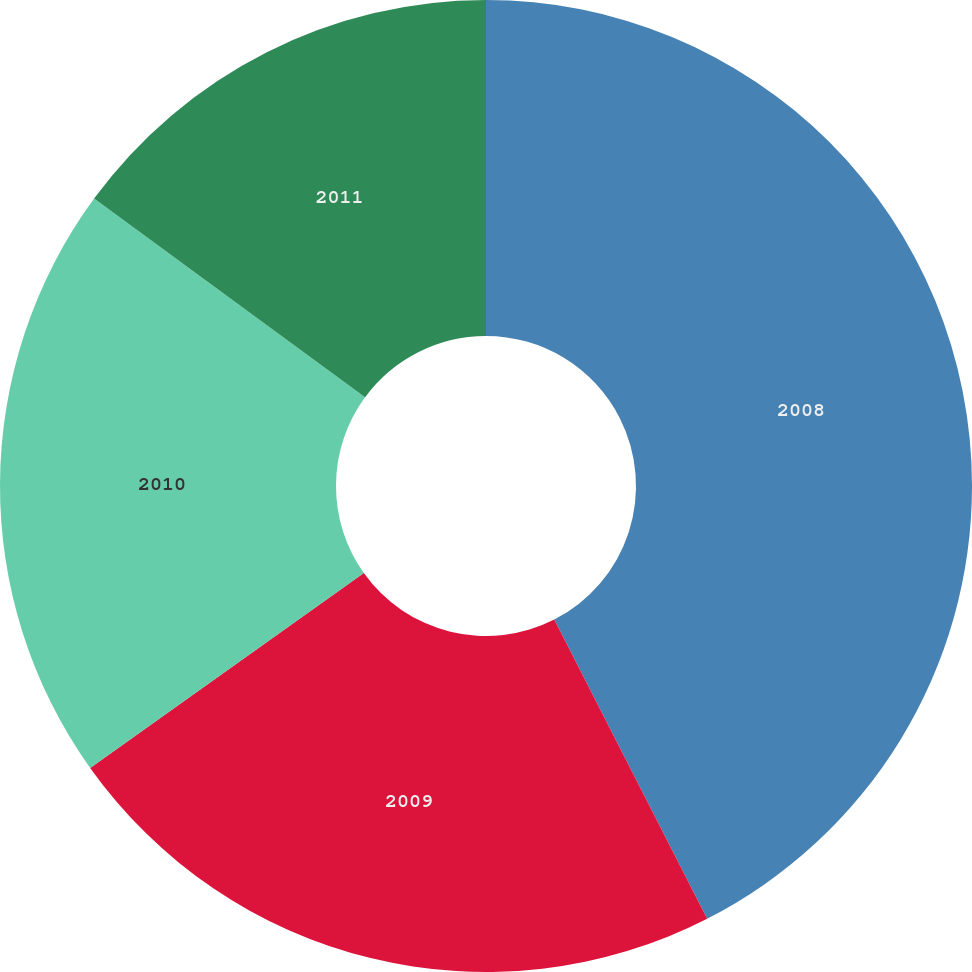<chart> <loc_0><loc_0><loc_500><loc_500><pie_chart><fcel>2008<fcel>2009<fcel>2010<fcel>2011<nl><fcel>42.48%<fcel>22.67%<fcel>19.92%<fcel>14.93%<nl></chart> 